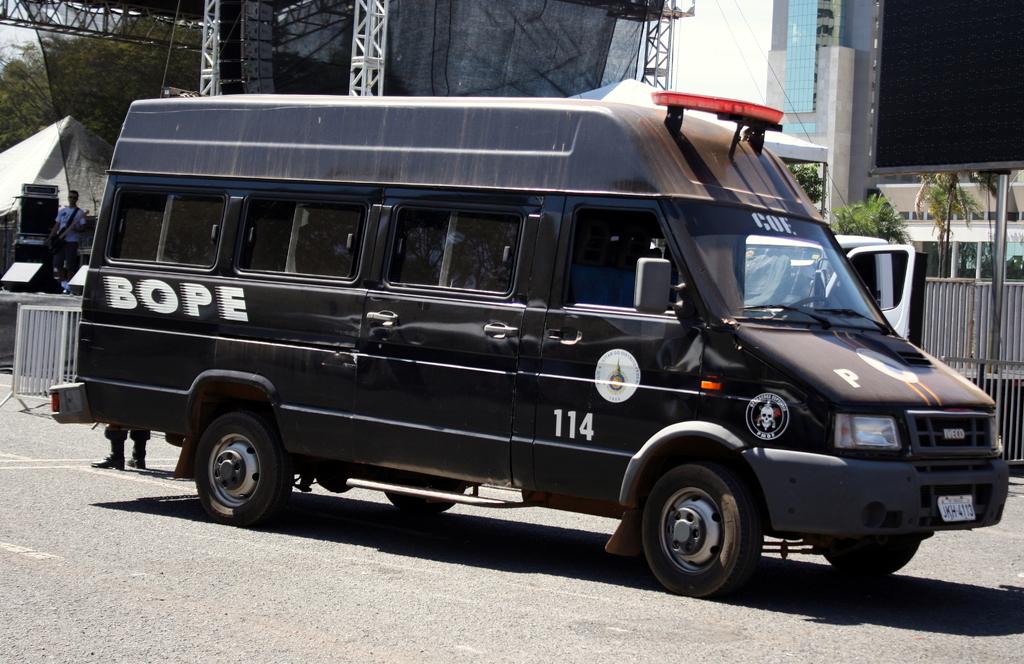What number is the van?
Keep it short and to the point. 114. What number is the van?
Give a very brief answer. 114. 